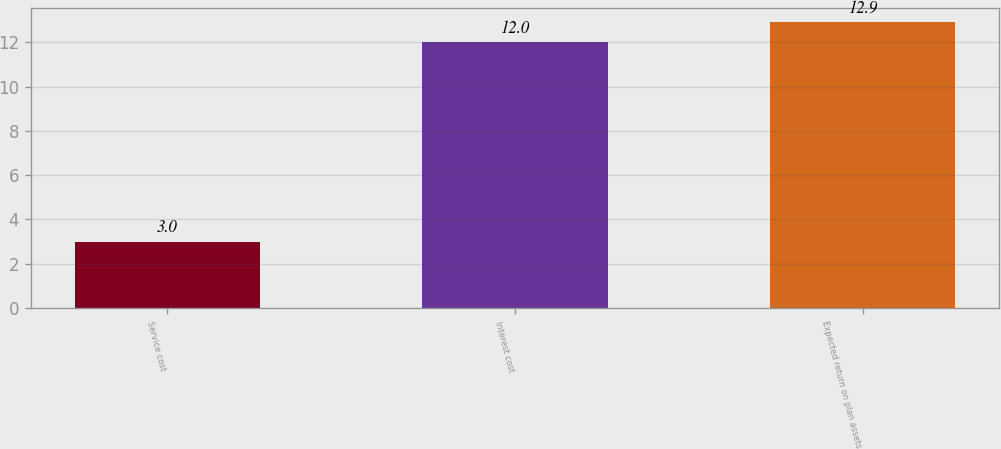<chart> <loc_0><loc_0><loc_500><loc_500><bar_chart><fcel>Service cost<fcel>Interest cost<fcel>Expected return on plan assets<nl><fcel>3<fcel>12<fcel>12.9<nl></chart> 